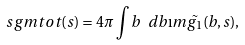Convert formula to latex. <formula><loc_0><loc_0><loc_500><loc_500>\ s g m t o t ( s ) = 4 \pi \int { b \ d b \i m { \tilde { g _ { 1 } } ( b , s ) } } ,</formula> 